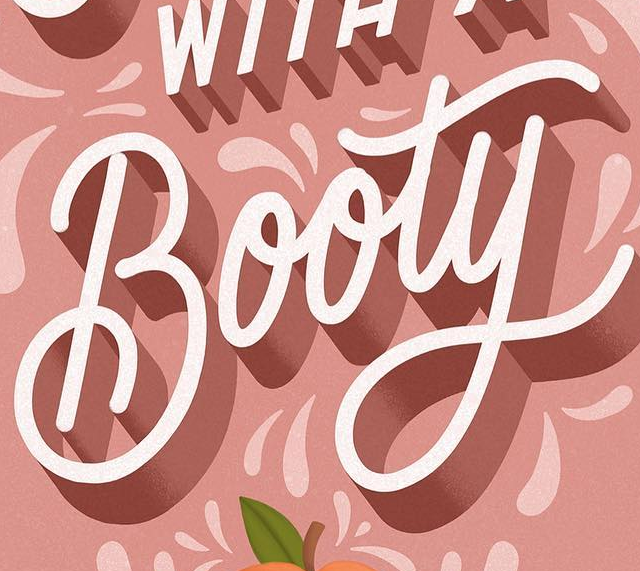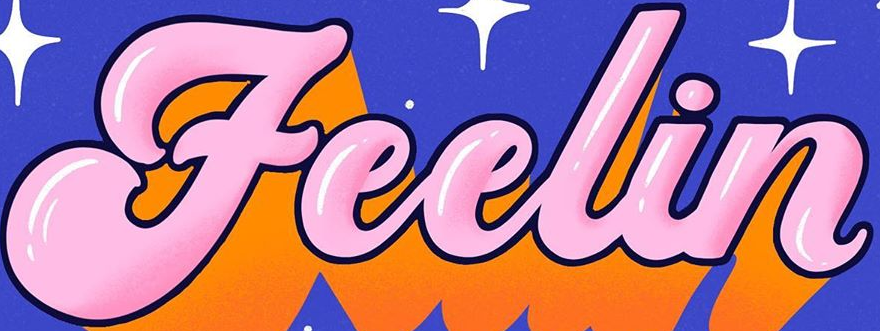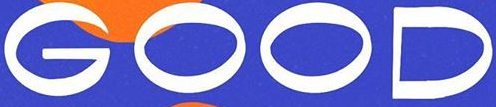What words can you see in these images in sequence, separated by a semicolon? Booty; Feelin; GOOD 